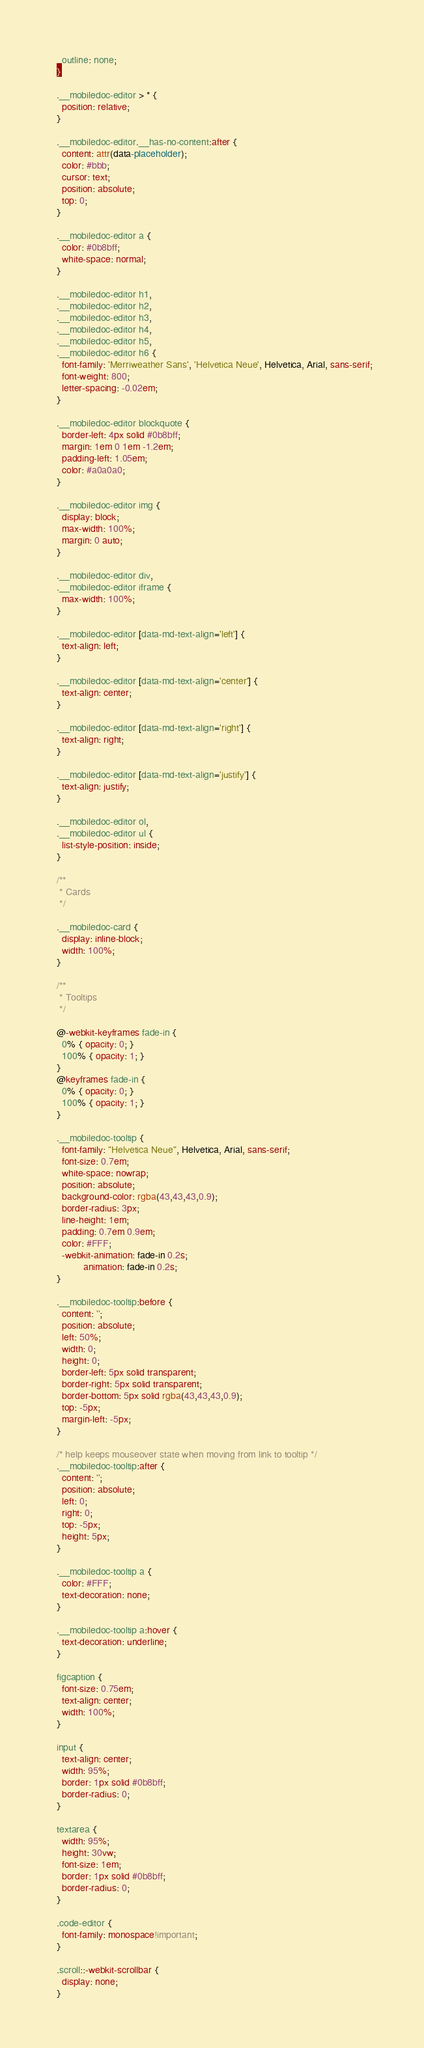Convert code to text. <code><loc_0><loc_0><loc_500><loc_500><_CSS_>    outline: none;
  }
  
  .__mobiledoc-editor > * {
    position: relative;
  }
  
  .__mobiledoc-editor.__has-no-content:after {
    content: attr(data-placeholder);
    color: #bbb;
    cursor: text;
    position: absolute;
    top: 0;
  }
  
  .__mobiledoc-editor a {
    color: #0b8bff;
    white-space: normal;
  }
  
  .__mobiledoc-editor h1,
  .__mobiledoc-editor h2,
  .__mobiledoc-editor h3,
  .__mobiledoc-editor h4,
  .__mobiledoc-editor h5,
  .__mobiledoc-editor h6 {
    font-family: 'Merriweather Sans', 'Helvetica Neue', Helvetica, Arial, sans-serif;
    font-weight: 800;
    letter-spacing: -0.02em;
  }

  .__mobiledoc-editor blockquote {
    border-left: 4px solid #0b8bff;
    margin: 1em 0 1em -1.2em;
    padding-left: 1.05em;
    color: #a0a0a0;
  }
  
  .__mobiledoc-editor img {
    display: block;
    max-width: 100%;
    margin: 0 auto;
  }
  
  .__mobiledoc-editor div,
  .__mobiledoc-editor iframe {
    max-width: 100%;
  }
  
  .__mobiledoc-editor [data-md-text-align='left'] {
    text-align: left;
  }
  
  .__mobiledoc-editor [data-md-text-align='center'] {
    text-align: center;
  }
  
  .__mobiledoc-editor [data-md-text-align='right'] {
    text-align: right;
  }
  
  .__mobiledoc-editor [data-md-text-align='justify'] {
    text-align: justify;
  }
  
  .__mobiledoc-editor ol,
  .__mobiledoc-editor ul {
    list-style-position: inside;
  }
  
  /**
   * Cards
   */
  
  .__mobiledoc-card {
    display: inline-block;
    width: 100%;
  }
  
  /**
   * Tooltips
   */
  
  @-webkit-keyframes fade-in {
    0% { opacity: 0; }
    100% { opacity: 1; }
  }
  @keyframes fade-in {
    0% { opacity: 0; }
    100% { opacity: 1; }
  }
  
  .__mobiledoc-tooltip {
    font-family: "Helvetica Neue", Helvetica, Arial, sans-serif;
    font-size: 0.7em;
    white-space: nowrap;
    position: absolute;
    background-color: rgba(43,43,43,0.9);
    border-radius: 3px;
    line-height: 1em;
    padding: 0.7em 0.9em;
    color: #FFF;
    -webkit-animation: fade-in 0.2s;
            animation: fade-in 0.2s;
  }
  
  .__mobiledoc-tooltip:before {
    content: '';
    position: absolute;
    left: 50%;
    width: 0;
    height: 0;
    border-left: 5px solid transparent;
    border-right: 5px solid transparent;
    border-bottom: 5px solid rgba(43,43,43,0.9);
    top: -5px;
    margin-left: -5px;
  }
  
  /* help keeps mouseover state when moving from link to tooltip */
  .__mobiledoc-tooltip:after {
    content: '';
    position: absolute;
    left: 0;
    right: 0;
    top: -5px;
    height: 5px;
  }
  
  .__mobiledoc-tooltip a {
    color: #FFF;
    text-decoration: none;
  }
  
  .__mobiledoc-tooltip a:hover {
    text-decoration: underline;
  }
  
  figcaption {
    font-size: 0.75em;
    text-align: center;
    width: 100%;
  }

  input {
    text-align: center;
    width: 95%;
    border: 1px solid #0b8bff;
    border-radius: 0;
  }
  
  textarea {
    width: 95%;
    height: 30vw;
    font-size: 1em;
    border: 1px solid #0b8bff;
    border-radius: 0;
  }

  .code-editor {
    font-family: monospace!important;
  }

  .scroll::-webkit-scrollbar {
    display: none;
  }</code> 